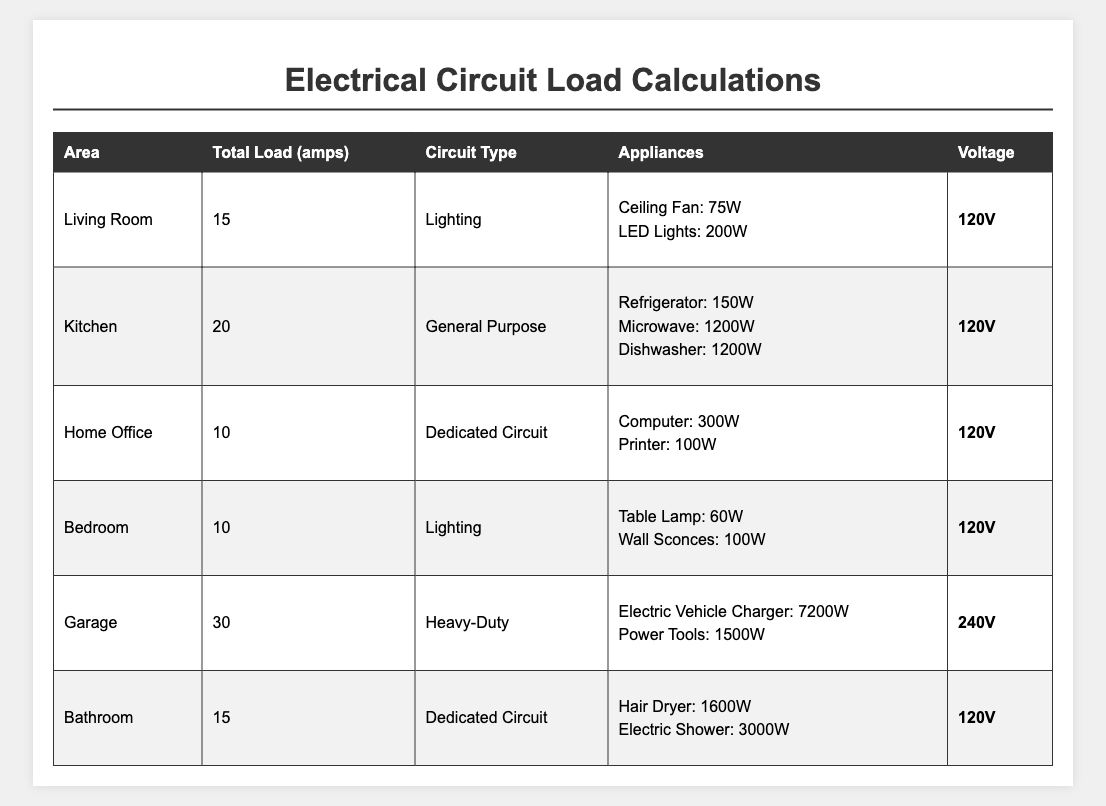What is the total load in amps for the Kitchen? The table shows that the Kitchen has a Total Load of 20 amps.
Answer: 20 amps How many different appliances are listed for the Living Room? The Living Room has two appliances listed: Ceiling Fan and LED Lights.
Answer: 2 appliances Is the voltage for the Garage circuit higher than the voltage for the Bedroom circuit? The Garage has a voltage of 240V, while the Bedroom has a voltage of 120V. Therefore, the Garage's voltage is higher.
Answer: Yes What is the total load in watts for appliances in the Bathroom? The appliances in the Bathroom are Hair Dryer (1600W) and Electric Shower (3000W). When added together, 1600 + 3000 = 4600 watts.
Answer: 4600 watts Which area has the highest total load in amps? The table shows that the highest total load is in the Garage, with 30 amps.
Answer: Garage What is the difference in total load between the Kitchen and the Bathroom? The Kitchen has a total load of 20 amps, and the Bathroom has 15 amps. The difference is 20 - 15 = 5 amps.
Answer: 5 amps What percentage of the total load in the Living Room is attributed to the LED Lights? The total load in the Living Room is 15 amps, which is equivalent to 1800 watts (15 amps × 120 volts). The LED Lights use 200 watts, so the percentage is (200 / 1800) × 100 = 11.11%.
Answer: 11.11% How many watts are being used by the appliances in the Home Office? The Home Office has a Computer (300W) and a Printer (100W). The total is 300 + 100 = 400 watts.
Answer: 400 watts Is the total load in the Garage more than double the total load in the Living Room? The Garage has a total load of 30 amps, and the Living Room has 15 amps. Double the Living Room's load would be 15 × 2 = 30 amps, which is equal to the Garage's load, not more.
Answer: No What is the average total load in amps across all areas? The total loads in amps are: 15 (Living Room) + 20 (Kitchen) + 10 (Home Office) + 10 (Bedroom) + 30 (Garage) + 15 (Bathroom) = 100 amps. There are 6 areas, so the average is 100 / 6 ≈ 16.67 amps.
Answer: 16.67 amps 